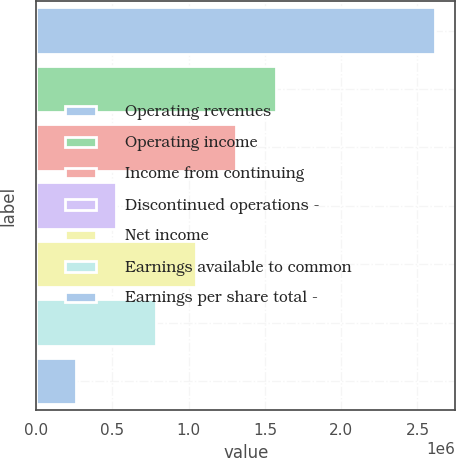Convert chart to OTSL. <chart><loc_0><loc_0><loc_500><loc_500><bar_chart><fcel>Operating revenues<fcel>Operating income<fcel>Income from continuing<fcel>Discontinued operations -<fcel>Net income<fcel>Earnings available to common<fcel>Earnings per share total -<nl><fcel>2.61812e+06<fcel>1.57087e+06<fcel>1.30906e+06<fcel>523623<fcel>1.04725e+06<fcel>785435<fcel>261812<nl></chart> 